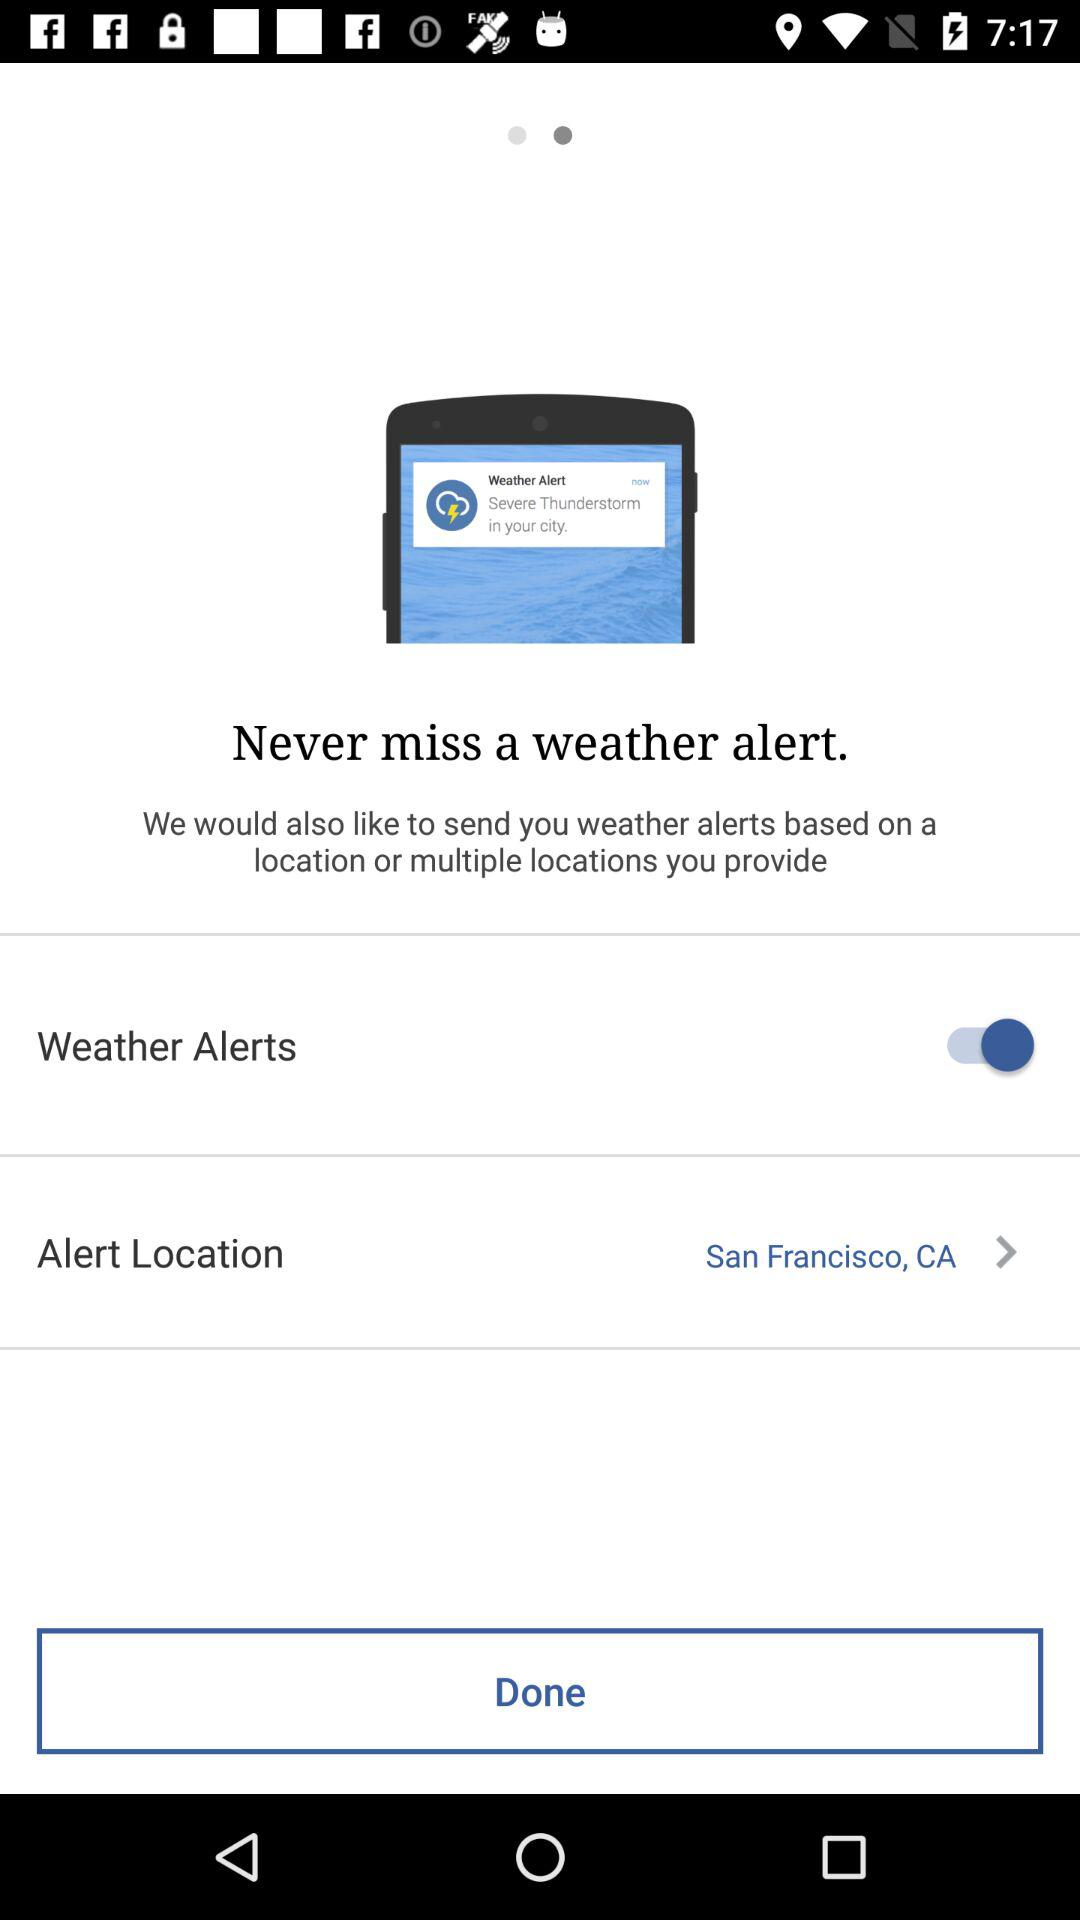What is the alert location? The alert location is San Francisco, CA. 